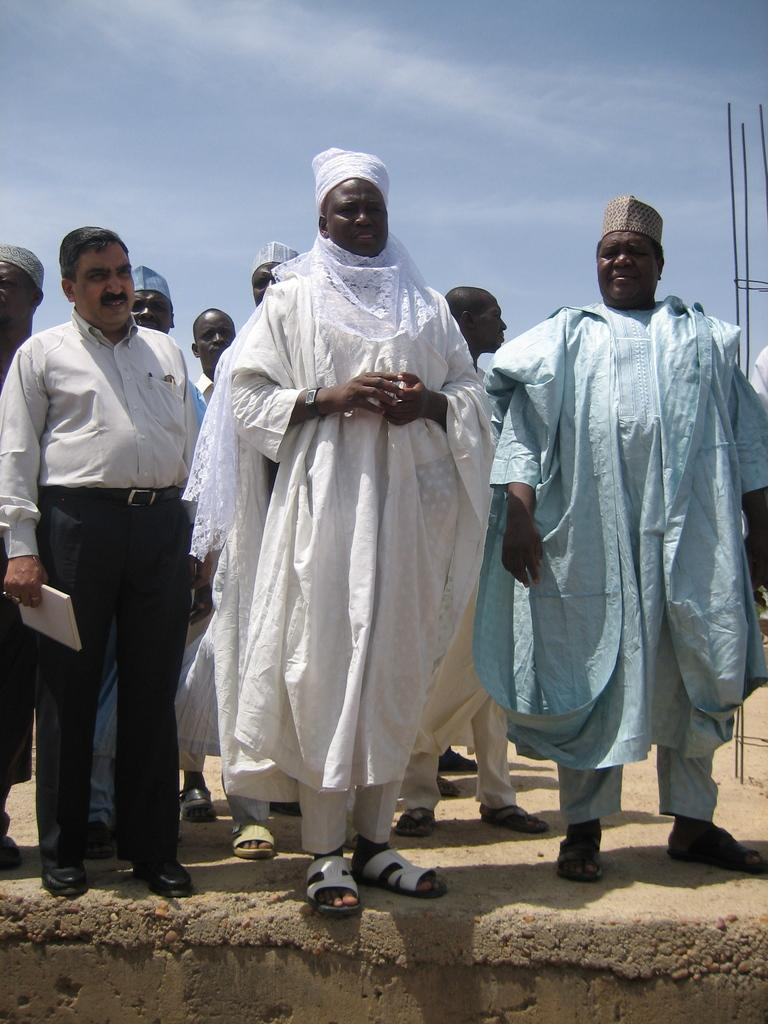What is the main subject in the foreground of the image? There are men in the foreground of the image. What are the men doing in the image? The men appear to be standing on a building. What can be seen in the background of the image? There are rods visible in the background of the image, and the sky is also visible. What type of arithmetic problem is being solved by the men in the image? There is no indication in the image that the men are solving an arithmetic problem. Can you describe the lip and neck features of the men in the image? There is no specific mention of the men's lips or necks in the image, so it is not possible to describe these features. 